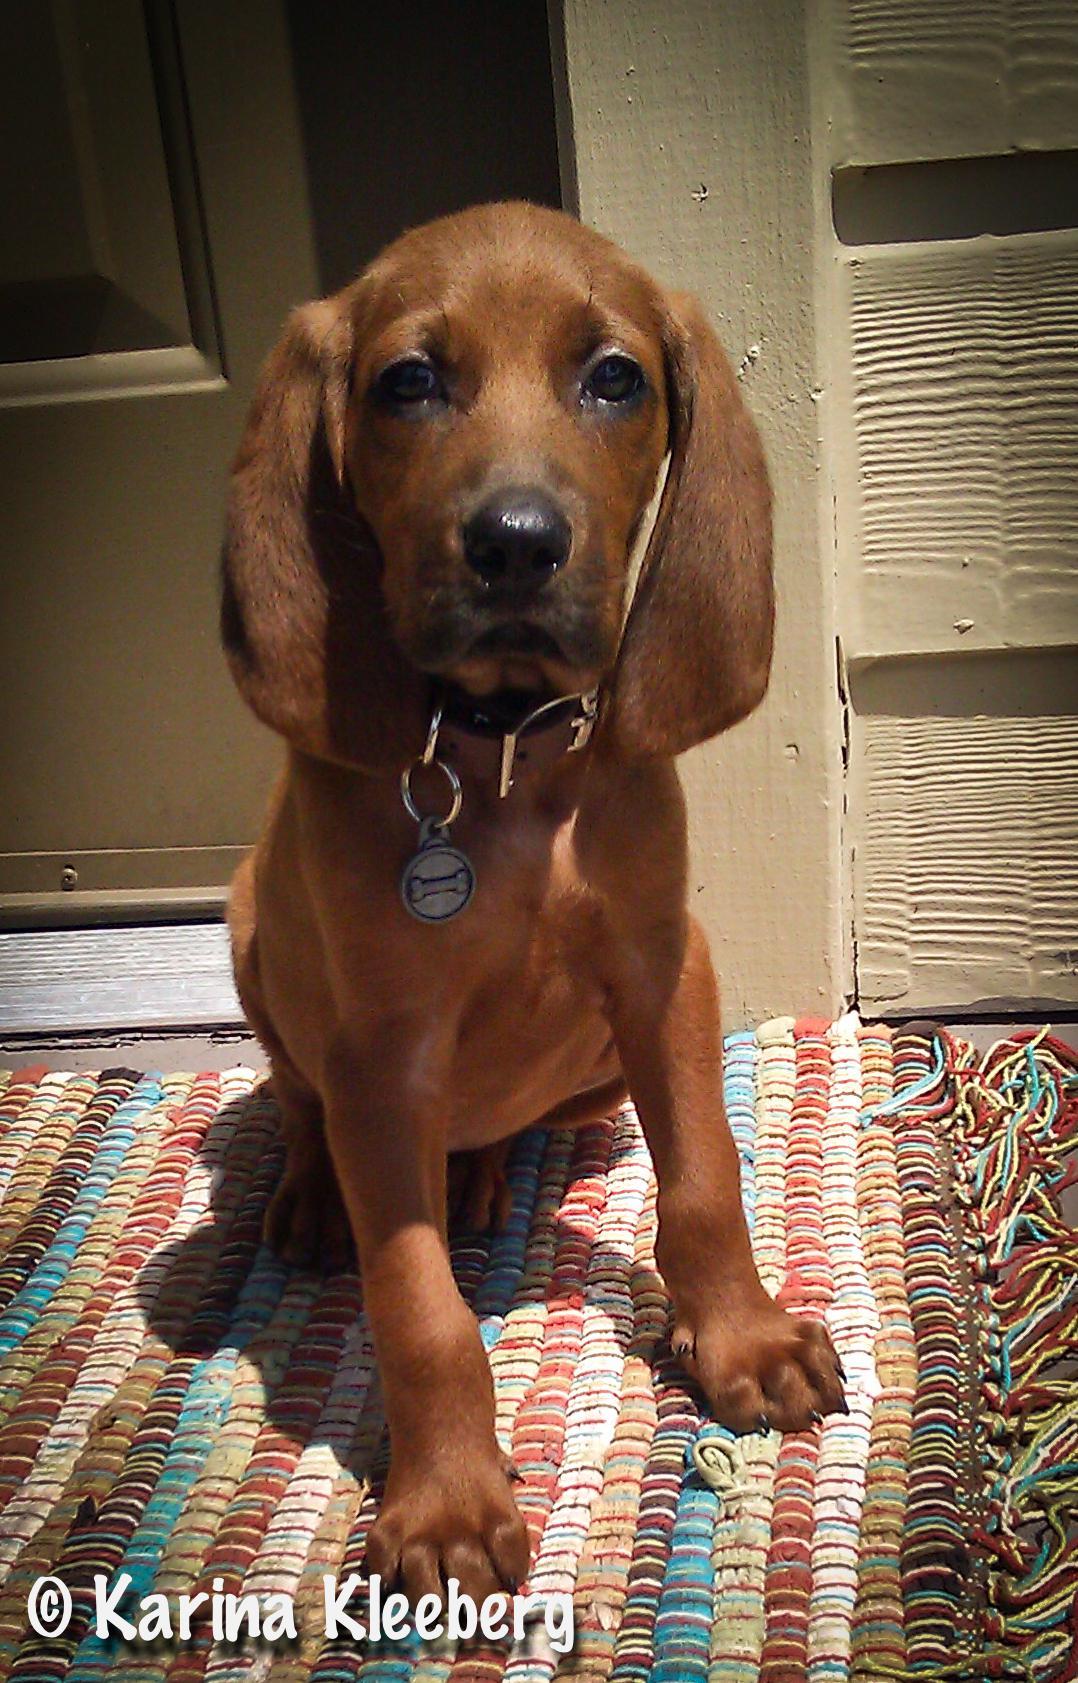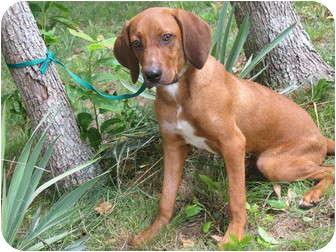The first image is the image on the left, the second image is the image on the right. Assess this claim about the two images: "At least three dogs are visible.". Correct or not? Answer yes or no. No. The first image is the image on the left, the second image is the image on the right. Given the left and right images, does the statement "At least two dogs with upright heads and shoulders are near a pair of legs in blue jeans." hold true? Answer yes or no. No. 